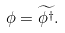Convert formula to latex. <formula><loc_0><loc_0><loc_500><loc_500>\phi = \widetilde { \phi ^ { \dag } } .</formula> 